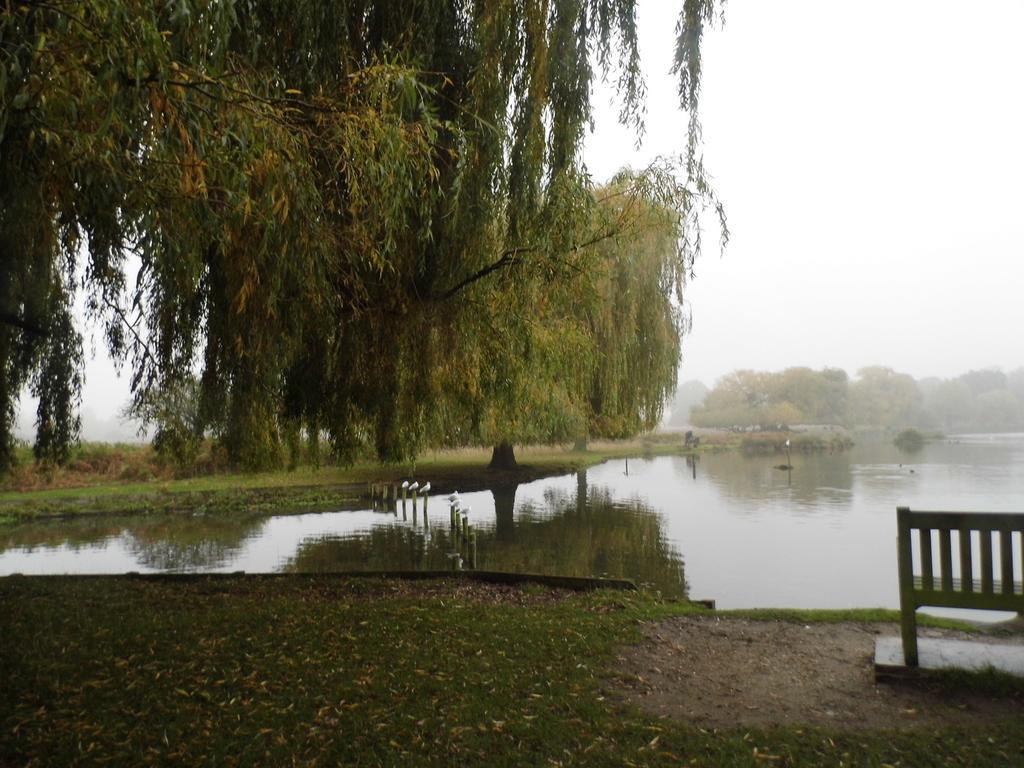In one or two sentences, can you explain what this image depicts? This image consists of trees. In the middle, there is water. At the bottom, there is ground. To the right, there is a bench. 